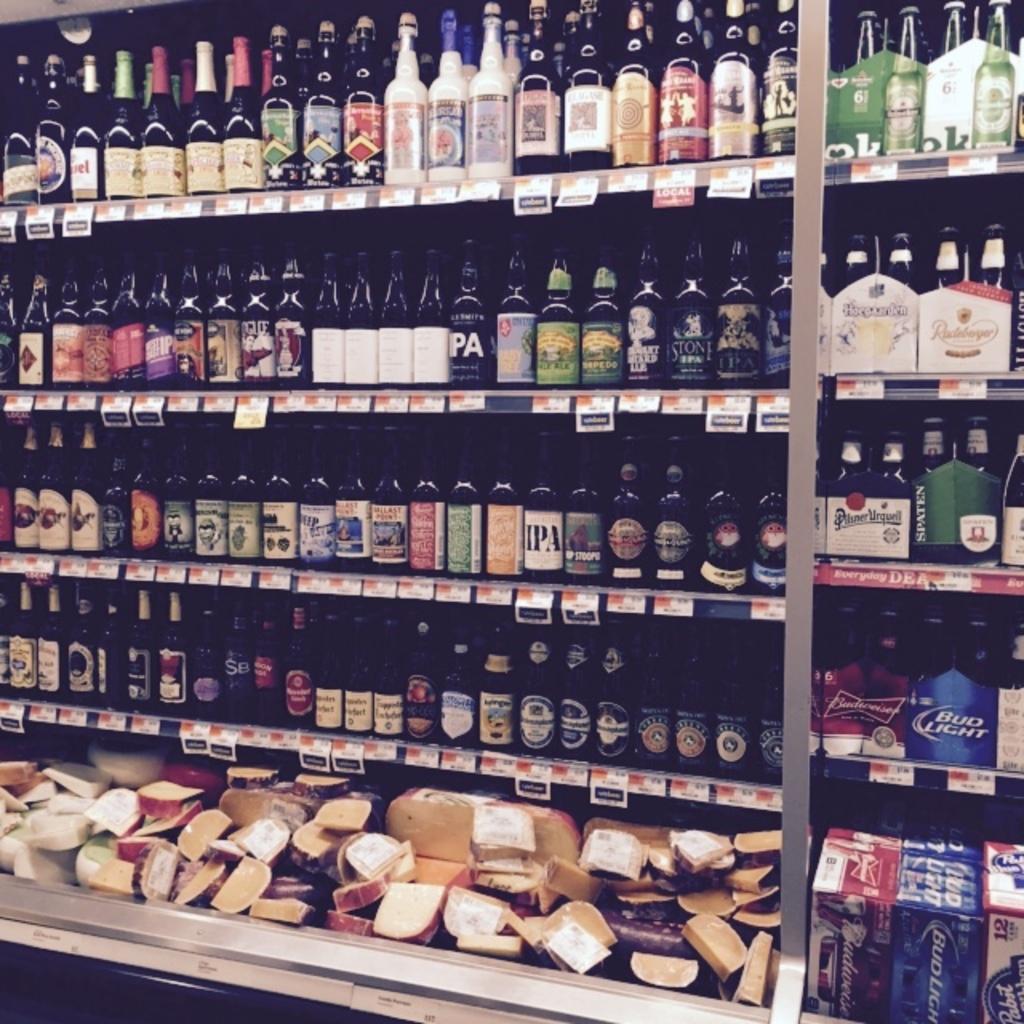What two letters on a bottle can you see on the second to top shelf?
Offer a very short reply. Pa. 